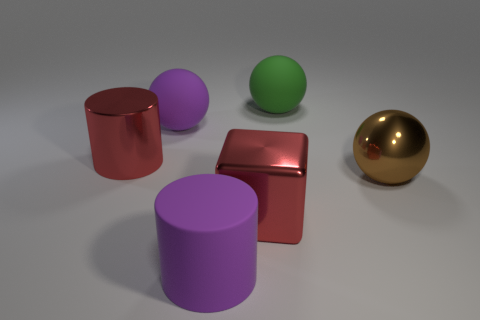Is the color of the metallic cylinder the same as the sphere that is in front of the red cylinder? No, the colors are distinct. The metallic cylinder appears to have a copper-like hue, whereas the sphere in front of the red cylinder is green, demonstrating a clear contrast in color. 